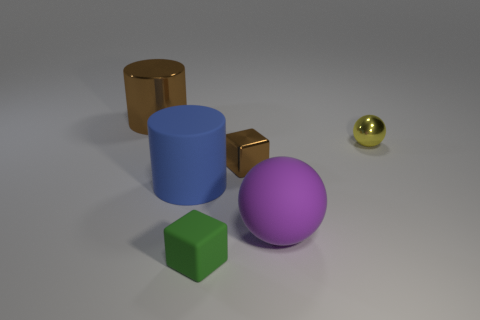Add 2 tiny yellow metallic spheres. How many objects exist? 8 Subtract all cubes. How many objects are left? 4 Add 2 large purple rubber spheres. How many large purple rubber spheres exist? 3 Subtract 0 gray cylinders. How many objects are left? 6 Subtract all big purple metal blocks. Subtract all brown metallic blocks. How many objects are left? 5 Add 4 brown cubes. How many brown cubes are left? 5 